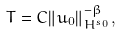<formula> <loc_0><loc_0><loc_500><loc_500>T = C \| u _ { 0 } \| _ { H ^ { s _ { 0 } } } ^ { - \beta } ,</formula> 